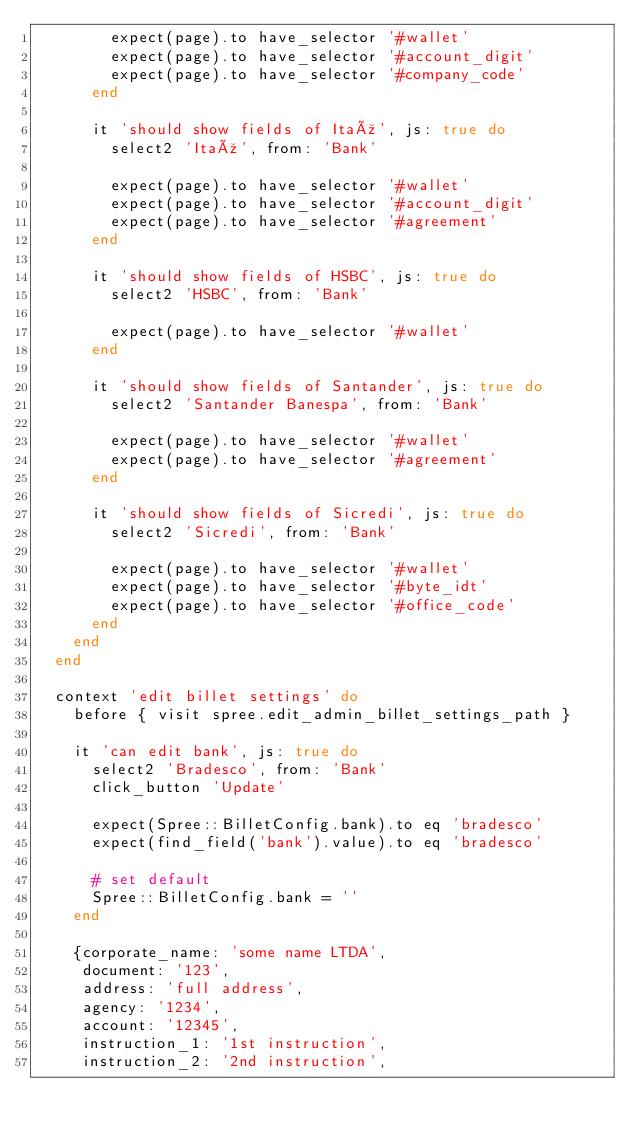<code> <loc_0><loc_0><loc_500><loc_500><_Ruby_>        expect(page).to have_selector '#wallet'
        expect(page).to have_selector '#account_digit'
        expect(page).to have_selector '#company_code'
      end

      it 'should show fields of Itaú', js: true do
        select2 'Itaú', from: 'Bank'

        expect(page).to have_selector '#wallet'
        expect(page).to have_selector '#account_digit'
        expect(page).to have_selector '#agreement'
      end

      it 'should show fields of HSBC', js: true do
        select2 'HSBC', from: 'Bank'

        expect(page).to have_selector '#wallet'
      end

      it 'should show fields of Santander', js: true do
        select2 'Santander Banespa', from: 'Bank'

        expect(page).to have_selector '#wallet'
        expect(page).to have_selector '#agreement'
      end

      it 'should show fields of Sicredi', js: true do
        select2 'Sicredi', from: 'Bank'

        expect(page).to have_selector '#wallet'
        expect(page).to have_selector '#byte_idt'
        expect(page).to have_selector '#office_code'
      end
    end
  end

  context 'edit billet settings' do
    before { visit spree.edit_admin_billet_settings_path }

    it 'can edit bank', js: true do
      select2 'Bradesco', from: 'Bank'
      click_button 'Update'

      expect(Spree::BilletConfig.bank).to eq 'bradesco'
      expect(find_field('bank').value).to eq 'bradesco'

      # set default
      Spree::BilletConfig.bank = ''
    end

    {corporate_name: 'some name LTDA',
     document: '123',
     address: 'full address',
     agency: '1234',
     account: '12345',
     instruction_1: '1st instruction',
     instruction_2: '2nd instruction',</code> 